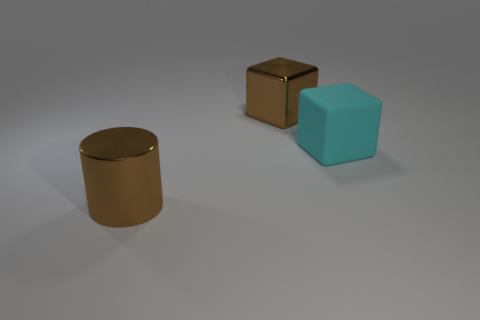Add 1 tiny metallic things. How many objects exist? 4 Subtract all blocks. How many objects are left? 1 Add 1 big brown metal cylinders. How many big brown metal cylinders exist? 2 Subtract 0 yellow blocks. How many objects are left? 3 Subtract all big brown metallic blocks. Subtract all brown shiny objects. How many objects are left? 0 Add 2 metal cubes. How many metal cubes are left? 3 